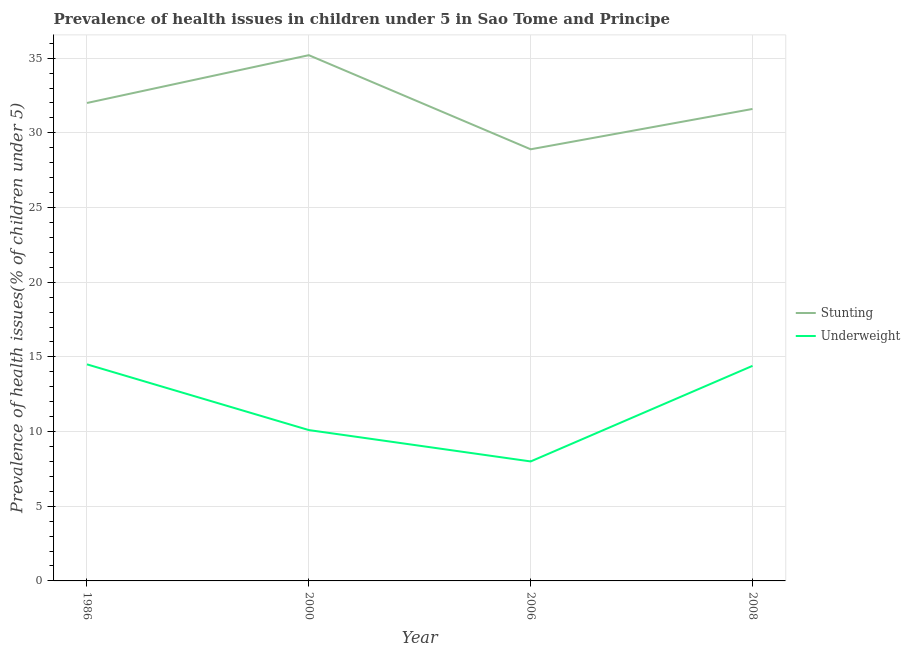How many different coloured lines are there?
Ensure brevity in your answer.  2. Does the line corresponding to percentage of stunted children intersect with the line corresponding to percentage of underweight children?
Provide a succinct answer. No. Is the number of lines equal to the number of legend labels?
Your answer should be very brief. Yes. What is the percentage of stunted children in 2008?
Ensure brevity in your answer.  31.6. Across all years, what is the maximum percentage of stunted children?
Your answer should be very brief. 35.2. Across all years, what is the minimum percentage of underweight children?
Keep it short and to the point. 8. In which year was the percentage of stunted children maximum?
Your response must be concise. 2000. In which year was the percentage of stunted children minimum?
Keep it short and to the point. 2006. What is the difference between the percentage of stunted children in 2006 and that in 2008?
Make the answer very short. -2.7. What is the difference between the percentage of stunted children in 2008 and the percentage of underweight children in 2006?
Provide a succinct answer. 23.6. What is the average percentage of underweight children per year?
Offer a very short reply. 11.75. In the year 1986, what is the difference between the percentage of underweight children and percentage of stunted children?
Ensure brevity in your answer.  -17.5. In how many years, is the percentage of stunted children greater than 18 %?
Your answer should be very brief. 4. What is the ratio of the percentage of underweight children in 1986 to that in 2008?
Your response must be concise. 1.01. Is the difference between the percentage of underweight children in 2000 and 2008 greater than the difference between the percentage of stunted children in 2000 and 2008?
Provide a succinct answer. No. What is the difference between the highest and the second highest percentage of stunted children?
Your response must be concise. 3.2. What is the difference between the highest and the lowest percentage of stunted children?
Your answer should be very brief. 6.3. Does the percentage of stunted children monotonically increase over the years?
Provide a short and direct response. No. Is the percentage of stunted children strictly greater than the percentage of underweight children over the years?
Keep it short and to the point. Yes. How many lines are there?
Your response must be concise. 2. How many years are there in the graph?
Give a very brief answer. 4. Are the values on the major ticks of Y-axis written in scientific E-notation?
Offer a terse response. No. Does the graph contain grids?
Your answer should be very brief. Yes. Where does the legend appear in the graph?
Give a very brief answer. Center right. How are the legend labels stacked?
Provide a short and direct response. Vertical. What is the title of the graph?
Your response must be concise. Prevalence of health issues in children under 5 in Sao Tome and Principe. Does "Commercial bank branches" appear as one of the legend labels in the graph?
Provide a succinct answer. No. What is the label or title of the X-axis?
Offer a terse response. Year. What is the label or title of the Y-axis?
Give a very brief answer. Prevalence of health issues(% of children under 5). What is the Prevalence of health issues(% of children under 5) in Stunting in 1986?
Give a very brief answer. 32. What is the Prevalence of health issues(% of children under 5) in Underweight in 1986?
Ensure brevity in your answer.  14.5. What is the Prevalence of health issues(% of children under 5) in Stunting in 2000?
Provide a succinct answer. 35.2. What is the Prevalence of health issues(% of children under 5) of Underweight in 2000?
Ensure brevity in your answer.  10.1. What is the Prevalence of health issues(% of children under 5) in Stunting in 2006?
Your response must be concise. 28.9. What is the Prevalence of health issues(% of children under 5) of Stunting in 2008?
Your answer should be very brief. 31.6. What is the Prevalence of health issues(% of children under 5) of Underweight in 2008?
Your response must be concise. 14.4. Across all years, what is the maximum Prevalence of health issues(% of children under 5) of Stunting?
Keep it short and to the point. 35.2. Across all years, what is the maximum Prevalence of health issues(% of children under 5) in Underweight?
Provide a succinct answer. 14.5. Across all years, what is the minimum Prevalence of health issues(% of children under 5) in Stunting?
Offer a terse response. 28.9. What is the total Prevalence of health issues(% of children under 5) of Stunting in the graph?
Offer a very short reply. 127.7. What is the difference between the Prevalence of health issues(% of children under 5) of Underweight in 1986 and that in 2000?
Your answer should be very brief. 4.4. What is the difference between the Prevalence of health issues(% of children under 5) of Underweight in 1986 and that in 2006?
Your answer should be compact. 6.5. What is the difference between the Prevalence of health issues(% of children under 5) in Underweight in 1986 and that in 2008?
Your response must be concise. 0.1. What is the difference between the Prevalence of health issues(% of children under 5) in Underweight in 2000 and that in 2006?
Make the answer very short. 2.1. What is the difference between the Prevalence of health issues(% of children under 5) in Stunting in 2000 and that in 2008?
Give a very brief answer. 3.6. What is the difference between the Prevalence of health issues(% of children under 5) of Stunting in 2006 and that in 2008?
Your answer should be compact. -2.7. What is the difference between the Prevalence of health issues(% of children under 5) of Underweight in 2006 and that in 2008?
Provide a short and direct response. -6.4. What is the difference between the Prevalence of health issues(% of children under 5) in Stunting in 1986 and the Prevalence of health issues(% of children under 5) in Underweight in 2000?
Offer a very short reply. 21.9. What is the difference between the Prevalence of health issues(% of children under 5) in Stunting in 2000 and the Prevalence of health issues(% of children under 5) in Underweight in 2006?
Provide a succinct answer. 27.2. What is the difference between the Prevalence of health issues(% of children under 5) of Stunting in 2000 and the Prevalence of health issues(% of children under 5) of Underweight in 2008?
Your answer should be very brief. 20.8. What is the difference between the Prevalence of health issues(% of children under 5) of Stunting in 2006 and the Prevalence of health issues(% of children under 5) of Underweight in 2008?
Provide a succinct answer. 14.5. What is the average Prevalence of health issues(% of children under 5) in Stunting per year?
Your response must be concise. 31.93. What is the average Prevalence of health issues(% of children under 5) of Underweight per year?
Your answer should be very brief. 11.75. In the year 2000, what is the difference between the Prevalence of health issues(% of children under 5) in Stunting and Prevalence of health issues(% of children under 5) in Underweight?
Offer a very short reply. 25.1. In the year 2006, what is the difference between the Prevalence of health issues(% of children under 5) of Stunting and Prevalence of health issues(% of children under 5) of Underweight?
Provide a short and direct response. 20.9. What is the ratio of the Prevalence of health issues(% of children under 5) in Underweight in 1986 to that in 2000?
Your answer should be very brief. 1.44. What is the ratio of the Prevalence of health issues(% of children under 5) of Stunting in 1986 to that in 2006?
Offer a terse response. 1.11. What is the ratio of the Prevalence of health issues(% of children under 5) in Underweight in 1986 to that in 2006?
Offer a terse response. 1.81. What is the ratio of the Prevalence of health issues(% of children under 5) of Stunting in 1986 to that in 2008?
Provide a short and direct response. 1.01. What is the ratio of the Prevalence of health issues(% of children under 5) in Underweight in 1986 to that in 2008?
Offer a very short reply. 1.01. What is the ratio of the Prevalence of health issues(% of children under 5) of Stunting in 2000 to that in 2006?
Your response must be concise. 1.22. What is the ratio of the Prevalence of health issues(% of children under 5) of Underweight in 2000 to that in 2006?
Your response must be concise. 1.26. What is the ratio of the Prevalence of health issues(% of children under 5) in Stunting in 2000 to that in 2008?
Your answer should be compact. 1.11. What is the ratio of the Prevalence of health issues(% of children under 5) of Underweight in 2000 to that in 2008?
Keep it short and to the point. 0.7. What is the ratio of the Prevalence of health issues(% of children under 5) of Stunting in 2006 to that in 2008?
Give a very brief answer. 0.91. What is the ratio of the Prevalence of health issues(% of children under 5) in Underweight in 2006 to that in 2008?
Provide a short and direct response. 0.56. What is the difference between the highest and the second highest Prevalence of health issues(% of children under 5) of Underweight?
Your response must be concise. 0.1. What is the difference between the highest and the lowest Prevalence of health issues(% of children under 5) of Underweight?
Your answer should be very brief. 6.5. 